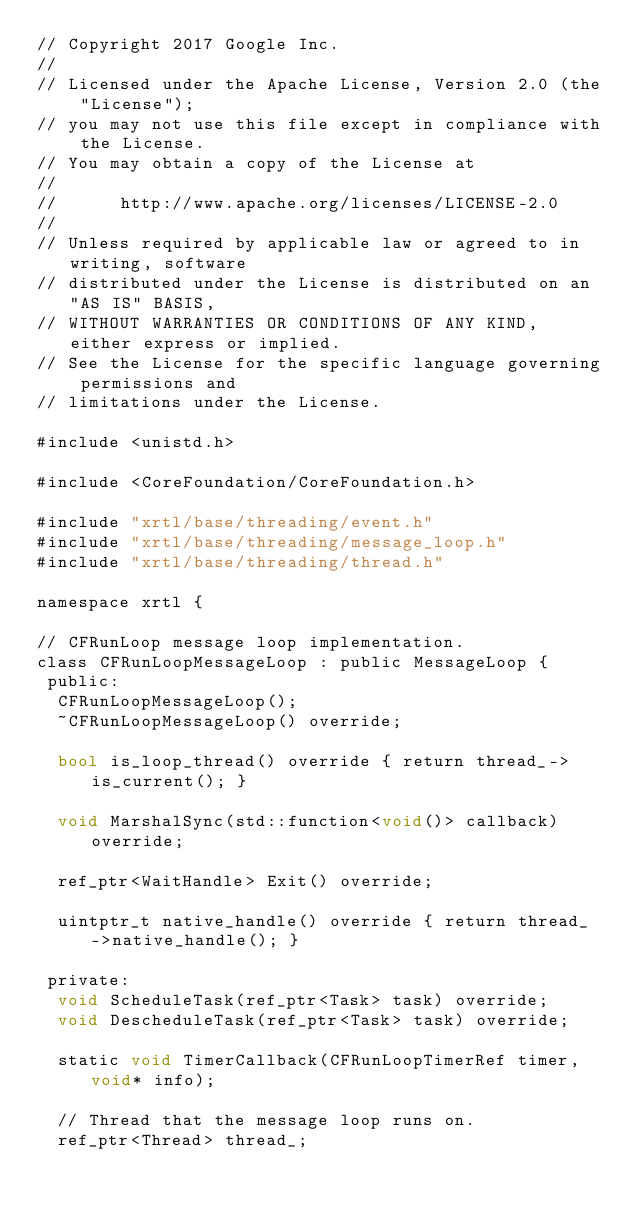<code> <loc_0><loc_0><loc_500><loc_500><_ObjectiveC_>// Copyright 2017 Google Inc.
//
// Licensed under the Apache License, Version 2.0 (the "License");
// you may not use this file except in compliance with the License.
// You may obtain a copy of the License at
//
//      http://www.apache.org/licenses/LICENSE-2.0
//
// Unless required by applicable law or agreed to in writing, software
// distributed under the License is distributed on an "AS IS" BASIS,
// WITHOUT WARRANTIES OR CONDITIONS OF ANY KIND, either express or implied.
// See the License for the specific language governing permissions and
// limitations under the License.

#include <unistd.h>

#include <CoreFoundation/CoreFoundation.h>

#include "xrtl/base/threading/event.h"
#include "xrtl/base/threading/message_loop.h"
#include "xrtl/base/threading/thread.h"

namespace xrtl {

// CFRunLoop message loop implementation.
class CFRunLoopMessageLoop : public MessageLoop {
 public:
  CFRunLoopMessageLoop();
  ~CFRunLoopMessageLoop() override;

  bool is_loop_thread() override { return thread_->is_current(); }

  void MarshalSync(std::function<void()> callback) override;

  ref_ptr<WaitHandle> Exit() override;

  uintptr_t native_handle() override { return thread_->native_handle(); }

 private:
  void ScheduleTask(ref_ptr<Task> task) override;
  void DescheduleTask(ref_ptr<Task> task) override;

  static void TimerCallback(CFRunLoopTimerRef timer, void* info);

  // Thread that the message loop runs on.
  ref_ptr<Thread> thread_;
</code> 